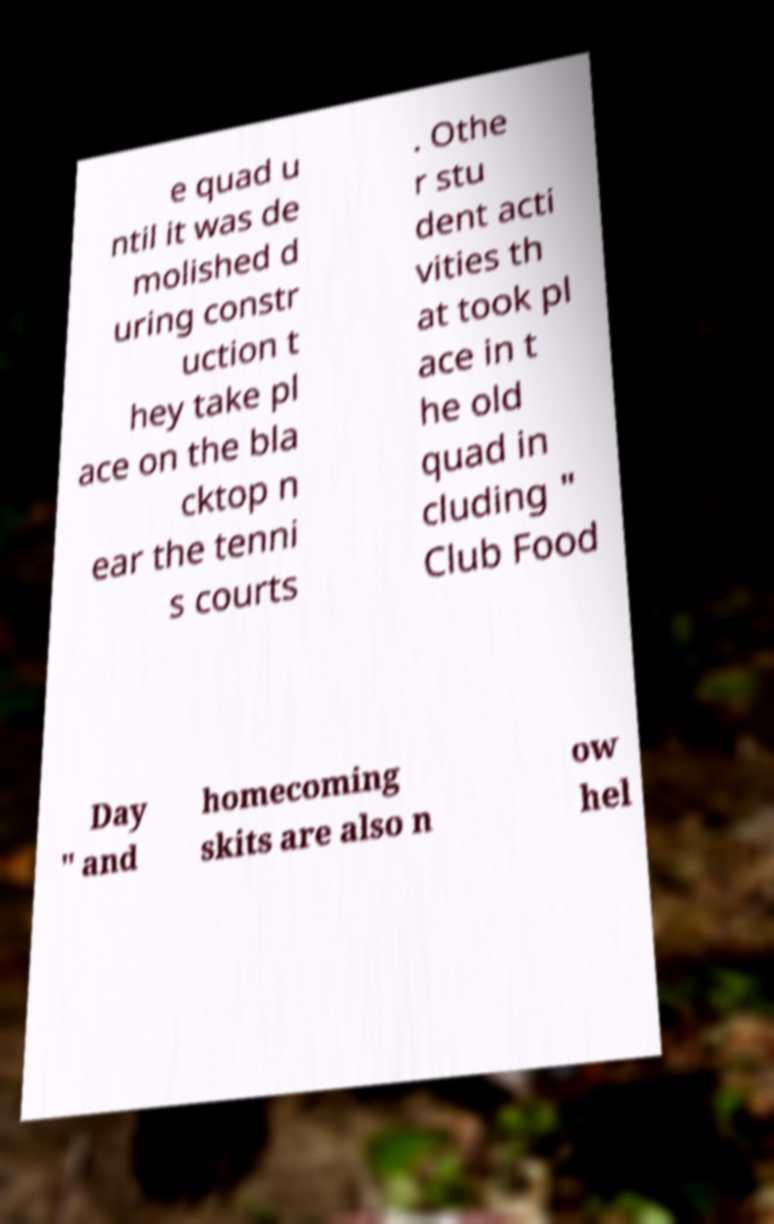I need the written content from this picture converted into text. Can you do that? e quad u ntil it was de molished d uring constr uction t hey take pl ace on the bla cktop n ear the tenni s courts . Othe r stu dent acti vities th at took pl ace in t he old quad in cluding " Club Food Day " and homecoming skits are also n ow hel 